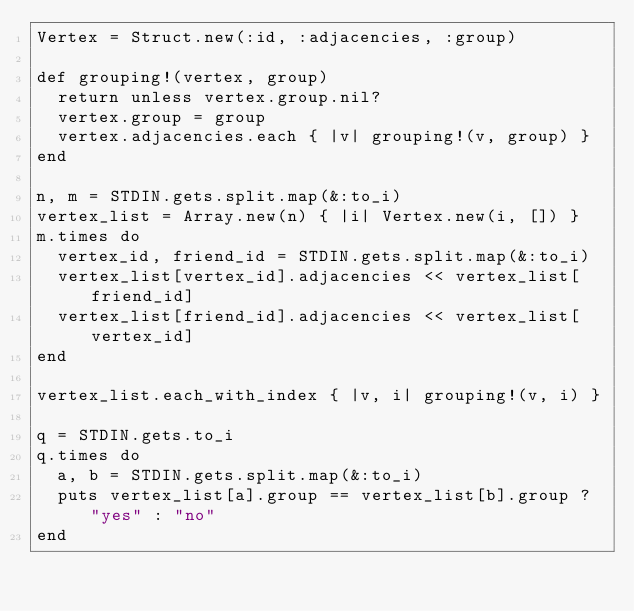Convert code to text. <code><loc_0><loc_0><loc_500><loc_500><_Ruby_>Vertex = Struct.new(:id, :adjacencies, :group)

def grouping!(vertex, group)
	return unless vertex.group.nil?
	vertex.group = group
	vertex.adjacencies.each { |v| grouping!(v, group) }
end

n, m = STDIN.gets.split.map(&:to_i)
vertex_list = Array.new(n) { |i| Vertex.new(i, []) }
m.times do
	vertex_id, friend_id = STDIN.gets.split.map(&:to_i)
	vertex_list[vertex_id].adjacencies << vertex_list[friend_id]
	vertex_list[friend_id].adjacencies << vertex_list[vertex_id]
end

vertex_list.each_with_index { |v, i| grouping!(v, i) }

q = STDIN.gets.to_i
q.times do
	a, b = STDIN.gets.split.map(&:to_i)
	puts vertex_list[a].group == vertex_list[b].group ? "yes" : "no"
end</code> 